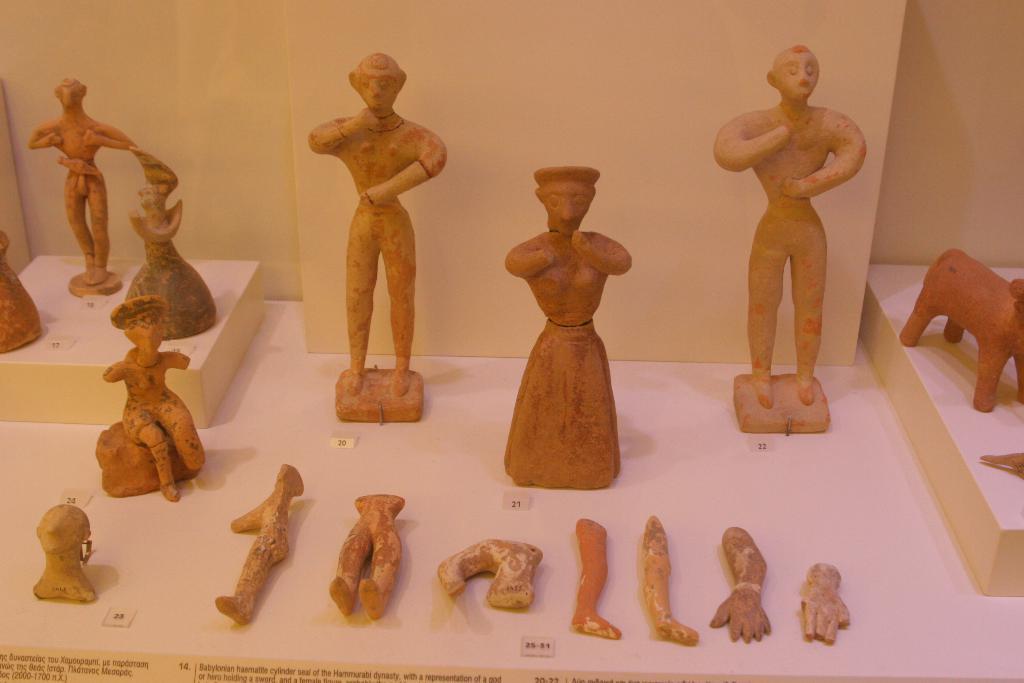Can you describe this image briefly? In the image we can see there are statues and antic pieces kept on the ground. 